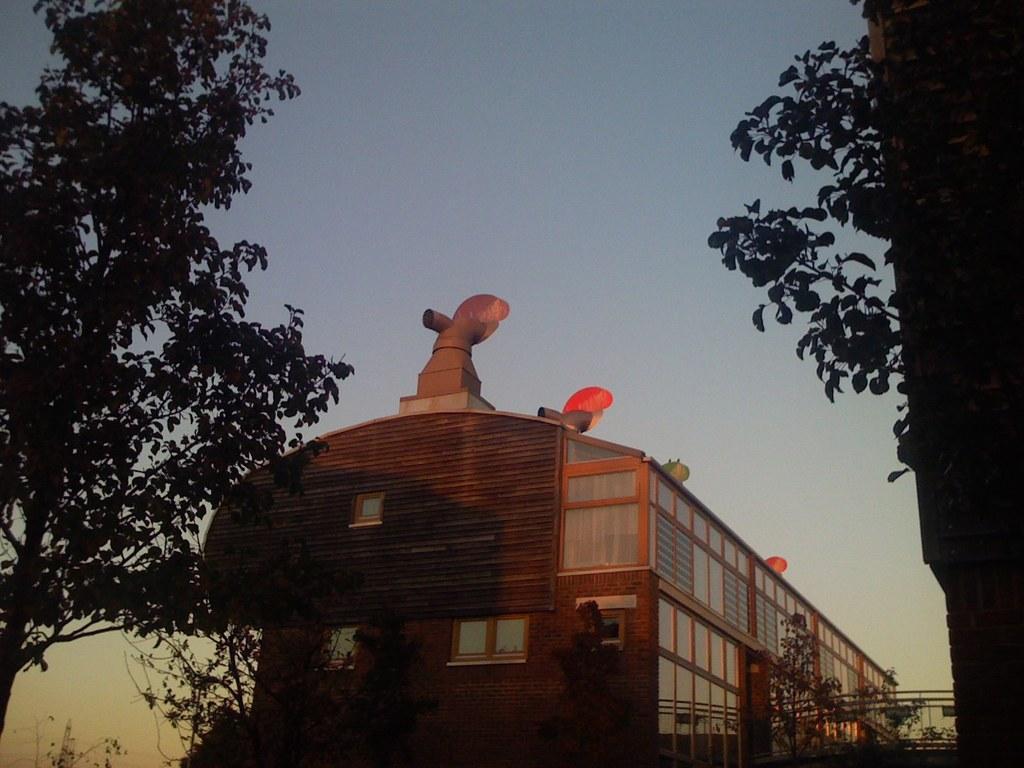Can you describe this image briefly? In this image I can see in the middle there is a building, there are trees on either side. At the top it is the sky. 